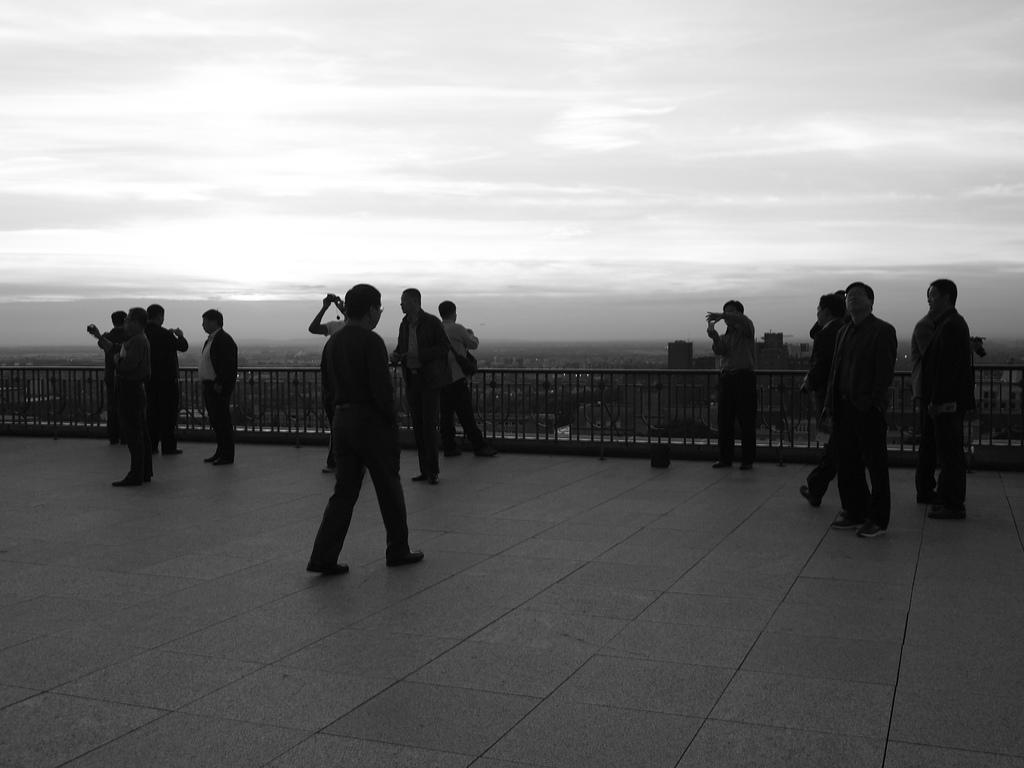How many people are in the image? There is a group of people standing in the image. What type of architectural feature can be seen in the image? There are iron grilles in the image. What structures are visible in the image? There are buildings in the image. What can be seen in the background of the image? The sky is visible in the background of the image. What type of straw is being used by the people in the image? There is no straw present in the image. What unit of measurement is being used to determine the height of the buildings in the image? The provided facts do not mention any specific unit of measurement for the buildings. 